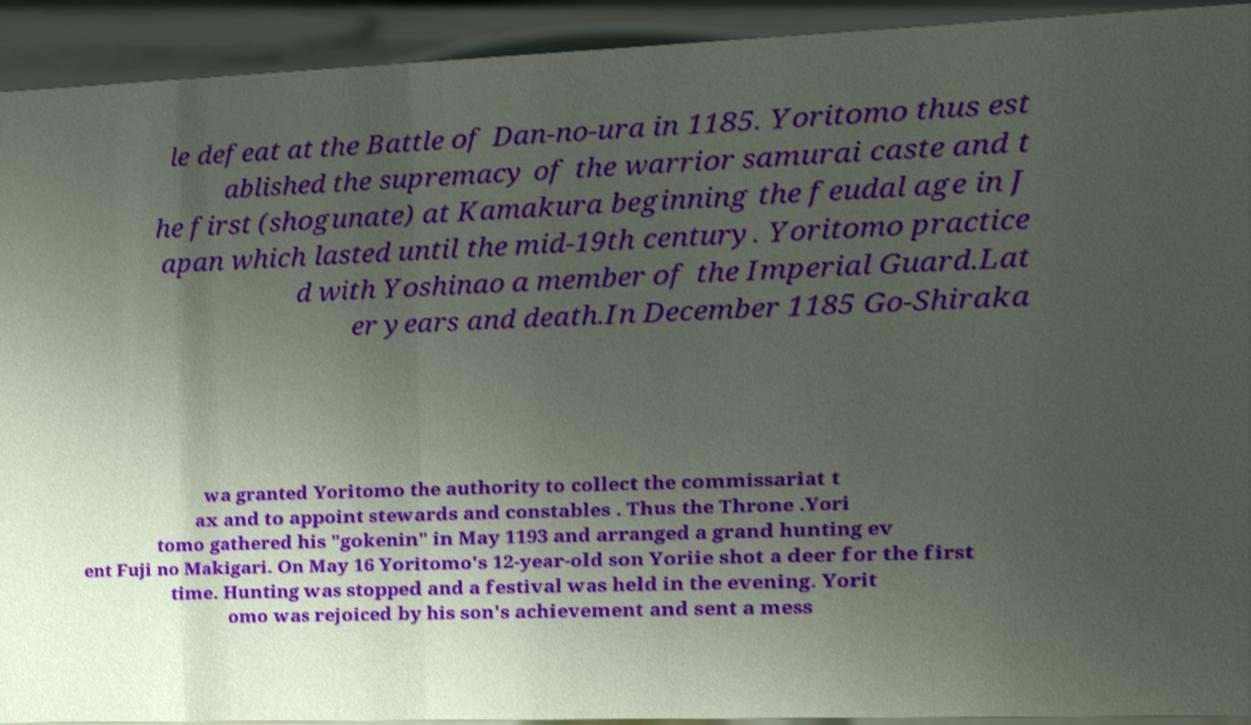What messages or text are displayed in this image? I need them in a readable, typed format. le defeat at the Battle of Dan-no-ura in 1185. Yoritomo thus est ablished the supremacy of the warrior samurai caste and t he first (shogunate) at Kamakura beginning the feudal age in J apan which lasted until the mid-19th century. Yoritomo practice d with Yoshinao a member of the Imperial Guard.Lat er years and death.In December 1185 Go-Shiraka wa granted Yoritomo the authority to collect the commissariat t ax and to appoint stewards and constables . Thus the Throne .Yori tomo gathered his "gokenin" in May 1193 and arranged a grand hunting ev ent Fuji no Makigari. On May 16 Yoritomo's 12-year-old son Yoriie shot a deer for the first time. Hunting was stopped and a festival was held in the evening. Yorit omo was rejoiced by his son's achievement and sent a mess 